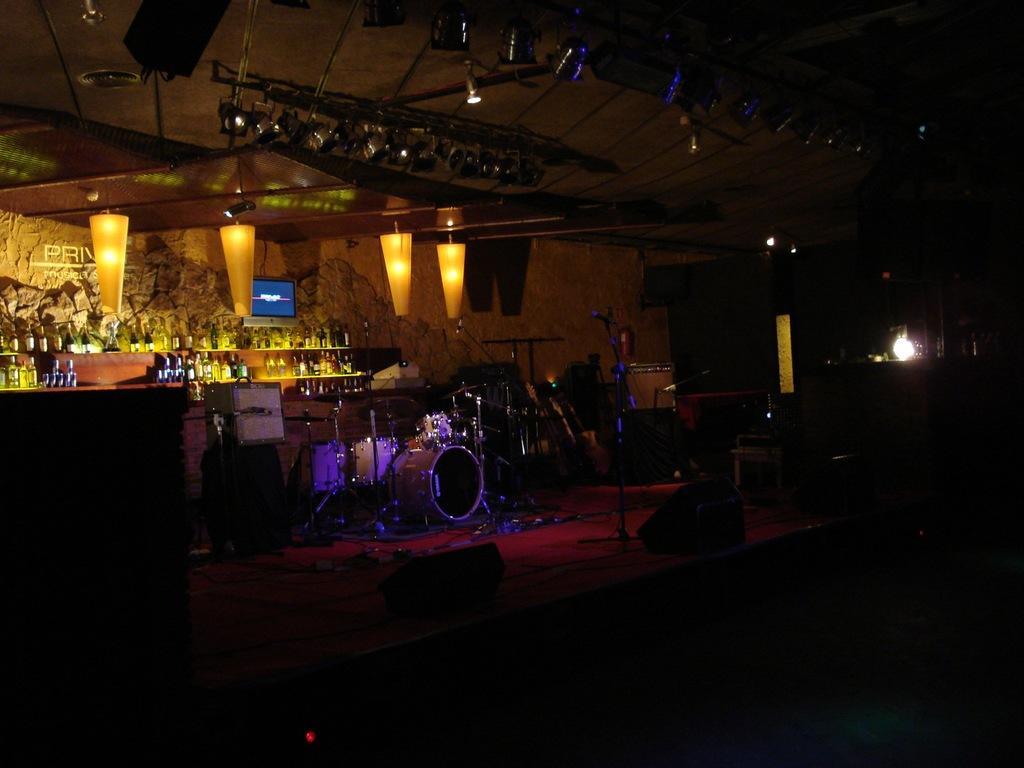Can you describe this image briefly? In this image we can see many musical instruments on the stage. There are many bottles in the image. There are many lights in the image. There are few objects at the right side of the image. 